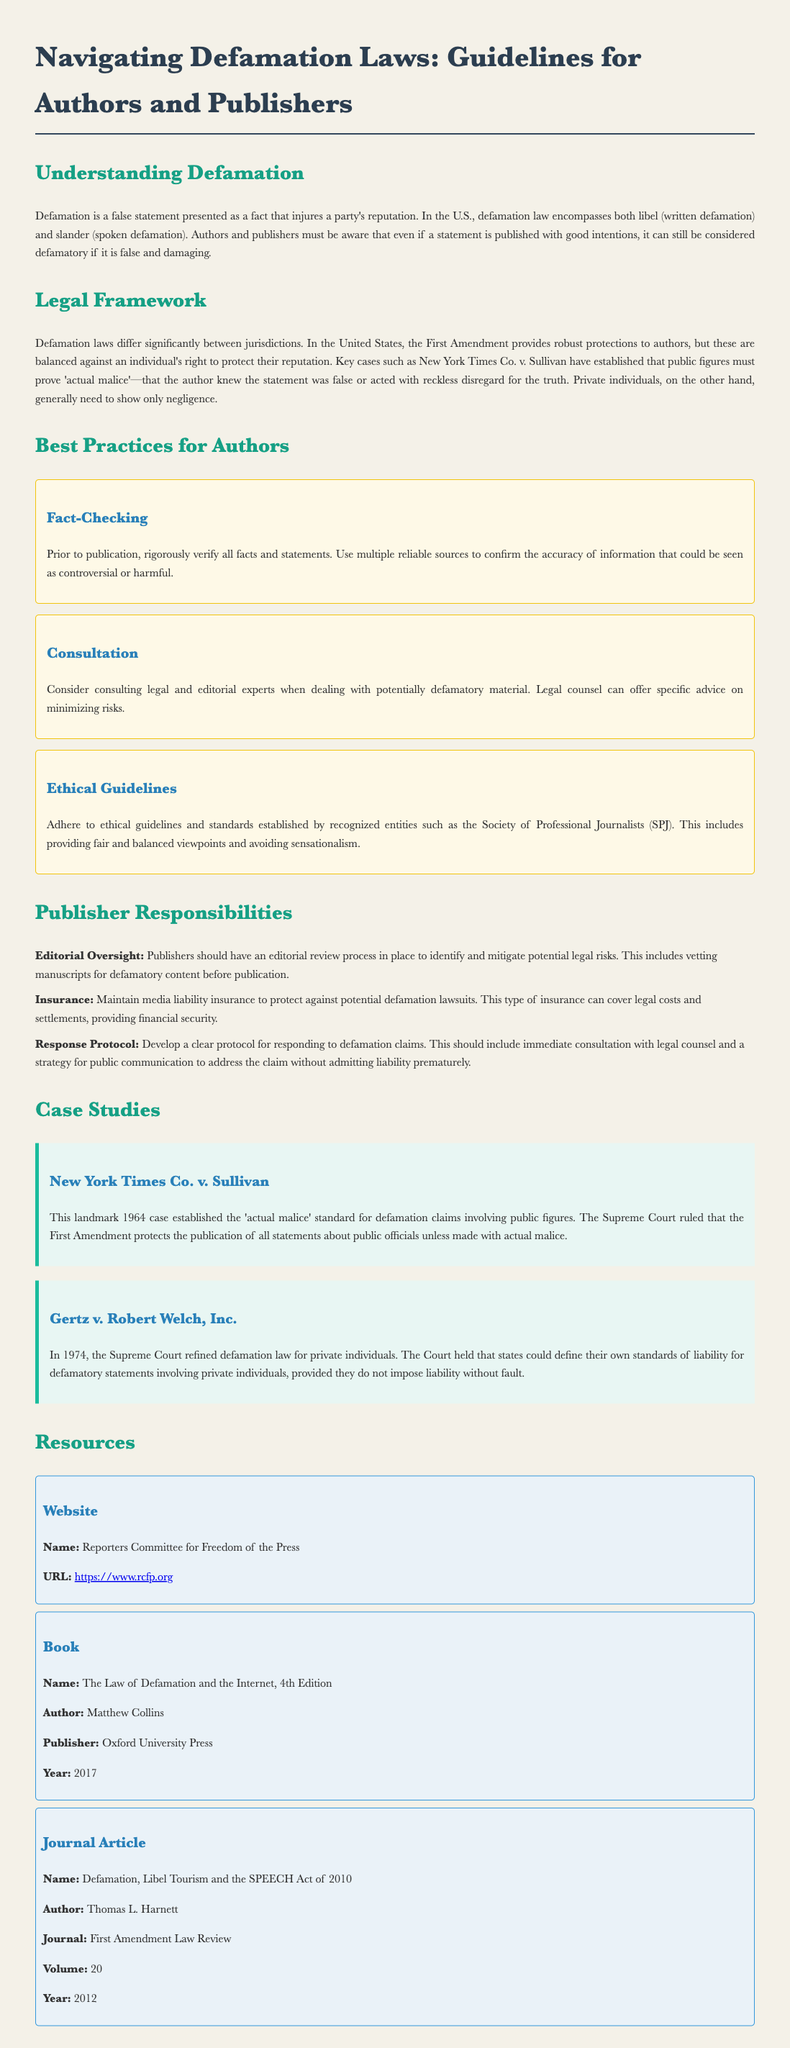What is the primary focus of the document? The document focuses on providing guidelines for authors and publishers regarding defamation laws.
Answer: Defamation laws What case established the 'actual malice' standard? The case mentioned as establishing this standard is a significant Supreme Court ruling related to public figures and defamation claims.
Answer: New York Times Co. v. Sullivan What year was Gertz v. Robert Welch, Inc. decided? The year of the decision is specified in the case study section detailing another substantial Supreme Court case regarding defamation.
Answer: 1974 What is one of the best practices for authors mentioned in the document? The best practices section lists strategies for authors to comply with defamation laws, one of which is verifying facts rigorously before publication.
Answer: Fact-Checking What type of insurance should publishers maintain? The document discusses a specific type of insurance that provides financial protection against legal claims, crucial for publishers to manage risks.
Answer: Media liability insurance What organization’s ethical guidelines are recommended? The document suggests adhering to standards from a specific recognized entity that aims to ensure fairness and balance in reporting.
Answer: Society of Professional Journalists How should publishers respond to defamation claims? The document outlines a protocol for handling claims, emphasizing the importance of legal consultation and communication strategy.
Answer: Develop a clear protocol What is the publication year of the book cited as a resource? The document cites a book within the resource section that addresses laws concerning defamation and the internet, including its publication date.
Answer: 2017 